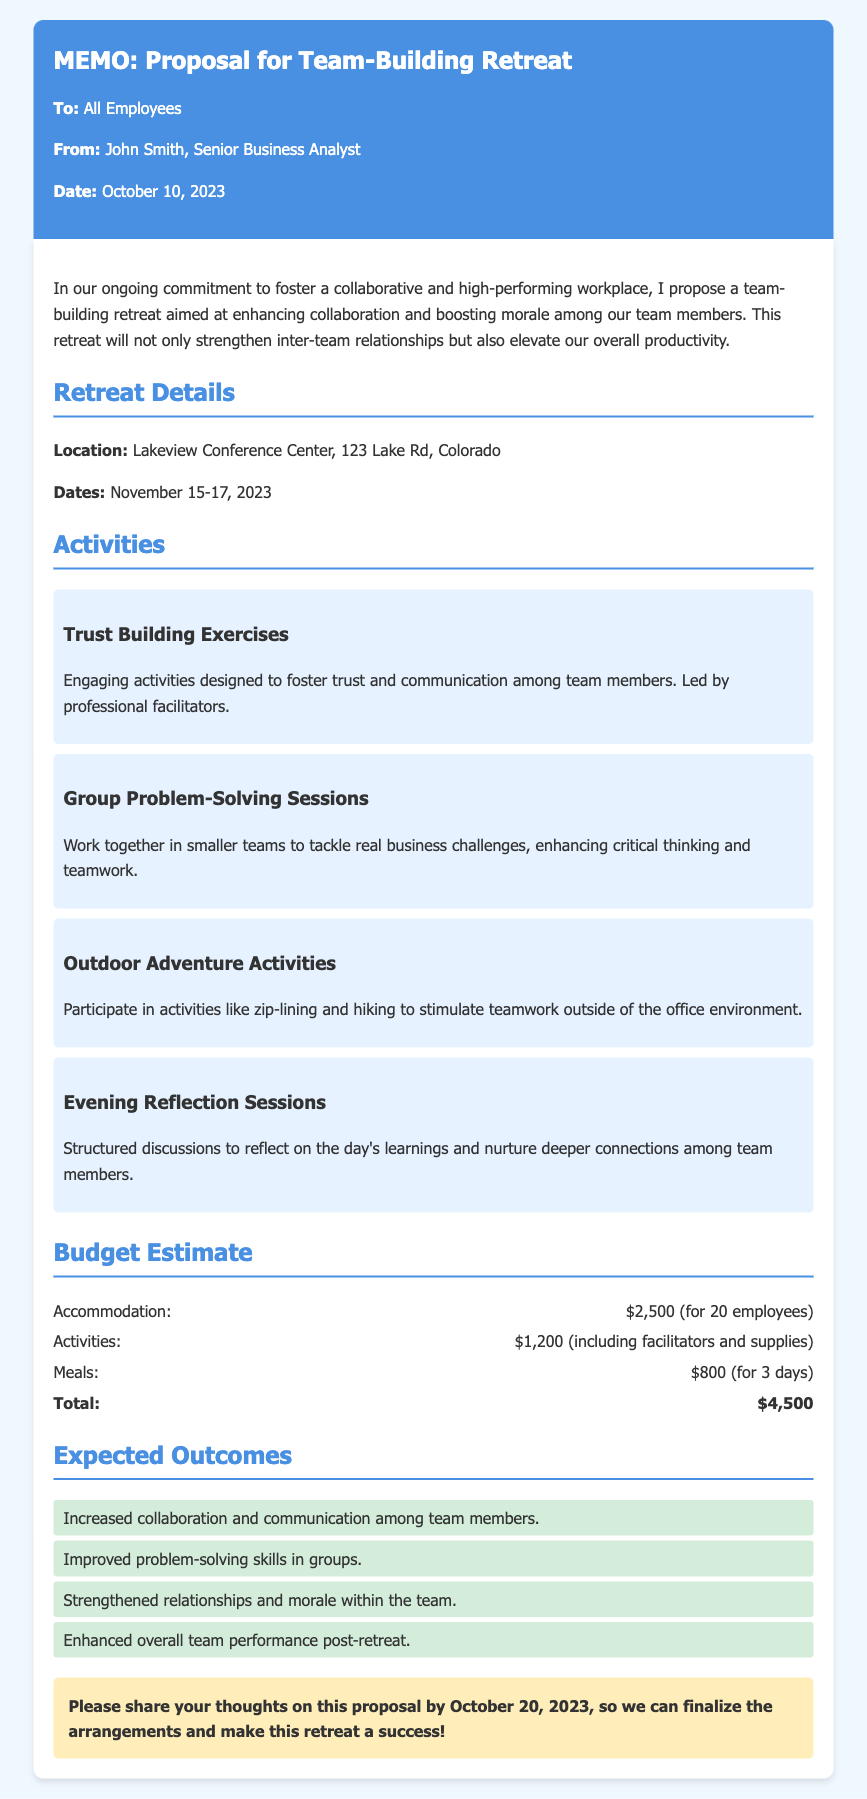What are the retreat dates? The retreat dates are mentioned specifically in the document, indicating when the team-building retreat will take place.
Answer: November 15-17, 2023 Who is the memo addressed to? The memo clearly states the recipient at the top, listing whom the content is directed towards.
Answer: All Employees Where is the retreat location? The location of the retreat is provided in the document as a crucial detail for the attendees.
Answer: Lakeview Conference Center, 123 Lake Rd, Colorado What is the total budget for the retreat? The total budget is summarized at the end of the budget estimate section, providing one clear figure.
Answer: $4,500 What kind of activities are planned for the retreat? The document lists various activities to be held during the retreat, highlighting what participants can expect.
Answer: Trust Building Exercises, Group Problem-Solving Sessions, Outdoor Adventure Activities, Evening Reflection Sessions What is one expected outcome of the retreat? The document states several positive outcomes anticipated from the retreat, emphasizing the benefits for team dynamics.
Answer: Increased collaboration and communication among team members By when should feedback on the proposal be shared? The memo requests feedback by a certain date, essential for planning purposes mentioned at the bottom.
Answer: October 20, 2023 Who is the author of the memo? The author is noted at the top of the document, giving credit to the person responsible for the proposal.
Answer: John Smith, Senior Business Analyst 